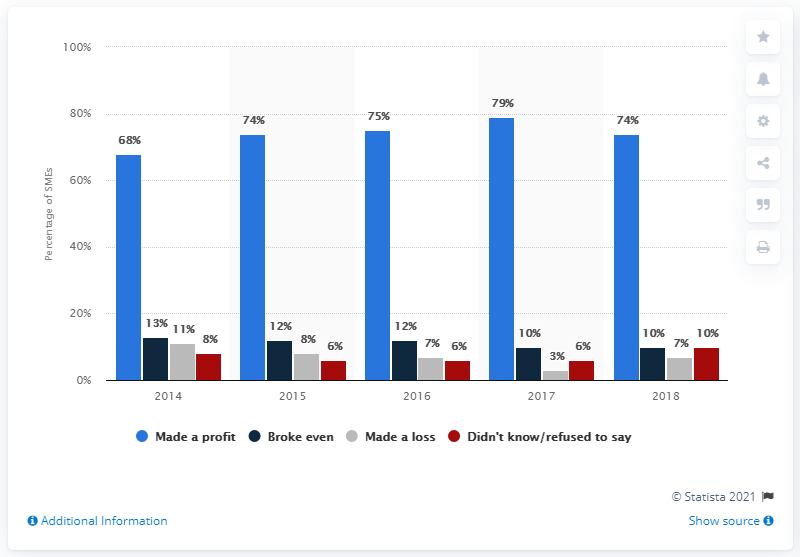Give some essential details in this illustration. In 2017, 74% of SMEs reported profits. In 2017, a significant portion of SMEs reported making a profit, making it the year with the highest share of SMEs that were profitable. 